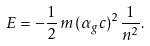Convert formula to latex. <formula><loc_0><loc_0><loc_500><loc_500>E = - \frac { 1 } { 2 } \, m \, ( \alpha _ { g } c ) ^ { 2 } \frac { 1 } { n ^ { 2 } } .</formula> 